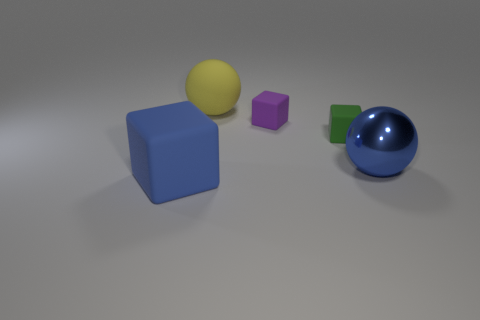Add 2 green things. How many objects exist? 7 Subtract all cubes. How many objects are left? 2 Add 5 large cubes. How many large cubes are left? 6 Add 2 blue metallic balls. How many blue metallic balls exist? 3 Subtract 0 green balls. How many objects are left? 5 Subtract all small yellow balls. Subtract all green matte objects. How many objects are left? 4 